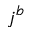Convert formula to latex. <formula><loc_0><loc_0><loc_500><loc_500>j ^ { b }</formula> 